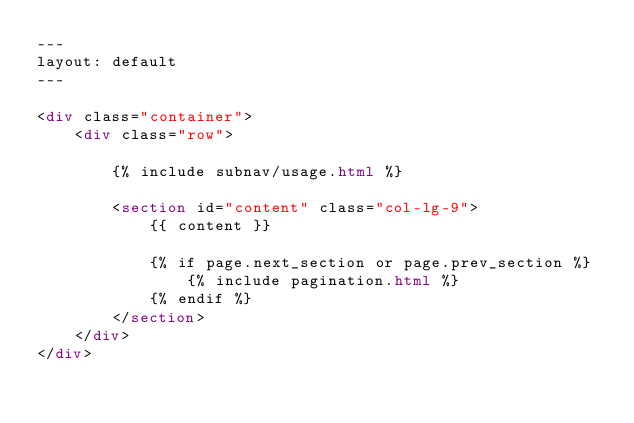Convert code to text. <code><loc_0><loc_0><loc_500><loc_500><_HTML_>---
layout: default
---
 
<div class="container">
    <div class="row">

        {% include subnav/usage.html %}

        <section id="content" class="col-lg-9">
            {{ content }}
            
            {% if page.next_section or page.prev_section %}
                {% include pagination.html %}
            {% endif %}
        </section>
    </div>
</div></code> 